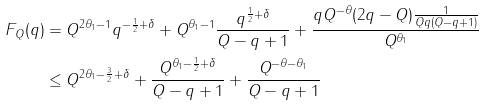<formula> <loc_0><loc_0><loc_500><loc_500>F _ { Q } ( q ) & = Q ^ { 2 \theta _ { 1 } - 1 } q ^ { - \frac { 1 } { 2 } + \delta } + Q ^ { \theta _ { 1 } - 1 } \frac { q ^ { \frac { 1 } { 2 } + \delta } } { Q - q + 1 } + \frac { q Q ^ { - \theta } ( 2 q - Q ) \frac { 1 } { Q q ( Q - q + 1 ) } } { Q ^ { \theta _ { 1 } } } \\ & \leq Q ^ { 2 \theta _ { 1 } - \frac { 3 } { 2 } + \delta } + \frac { Q ^ { \theta _ { 1 } - \frac { 1 } { 2 } + \delta } } { Q - q + 1 } + \frac { Q ^ { - \theta - \theta _ { 1 } } } { Q - q + 1 }</formula> 